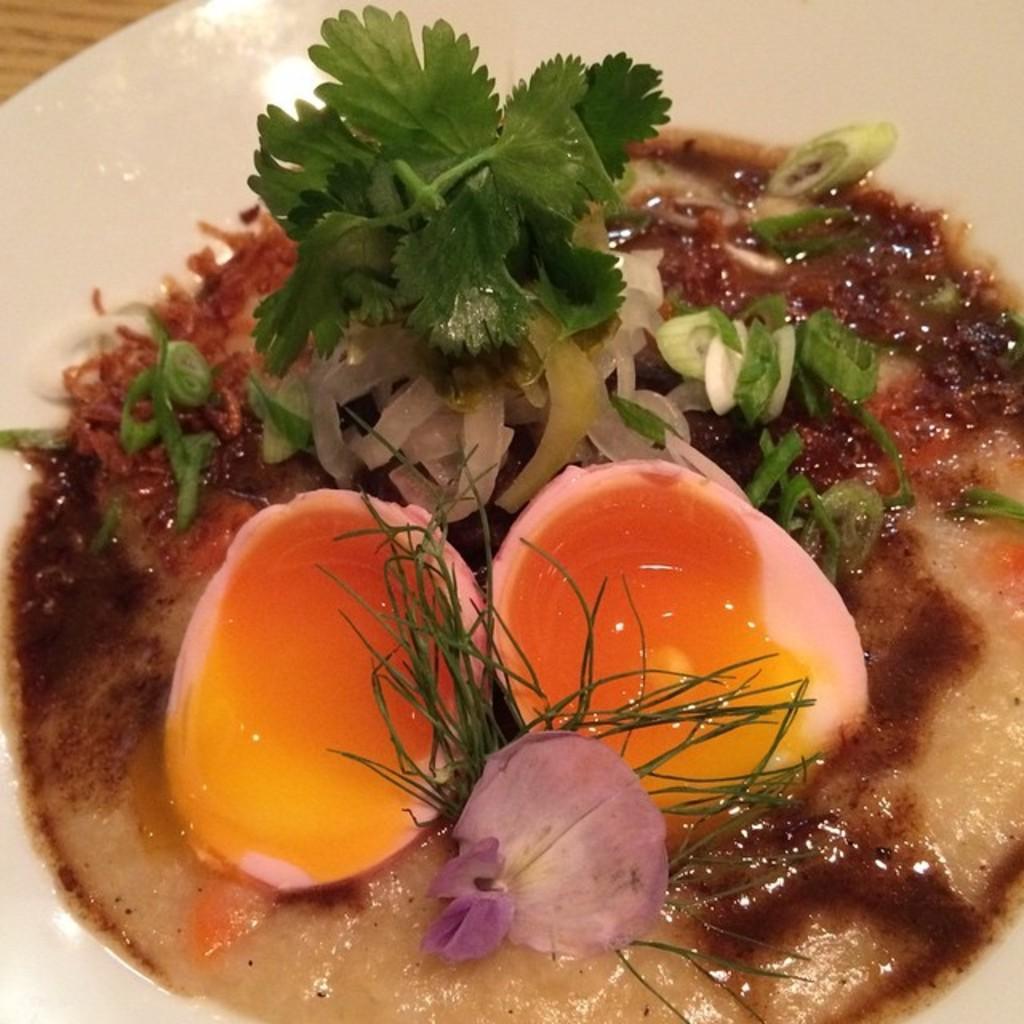Could you give a brief overview of what you see in this image? This is the picture of a plate in which there is a egg, slice of onion and some leafy vegetable on it. 